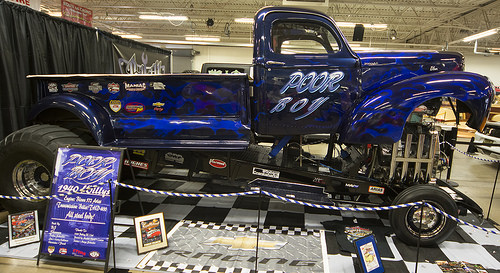<image>
Is the sign on the truck? No. The sign is not positioned on the truck. They may be near each other, but the sign is not supported by or resting on top of the truck. 